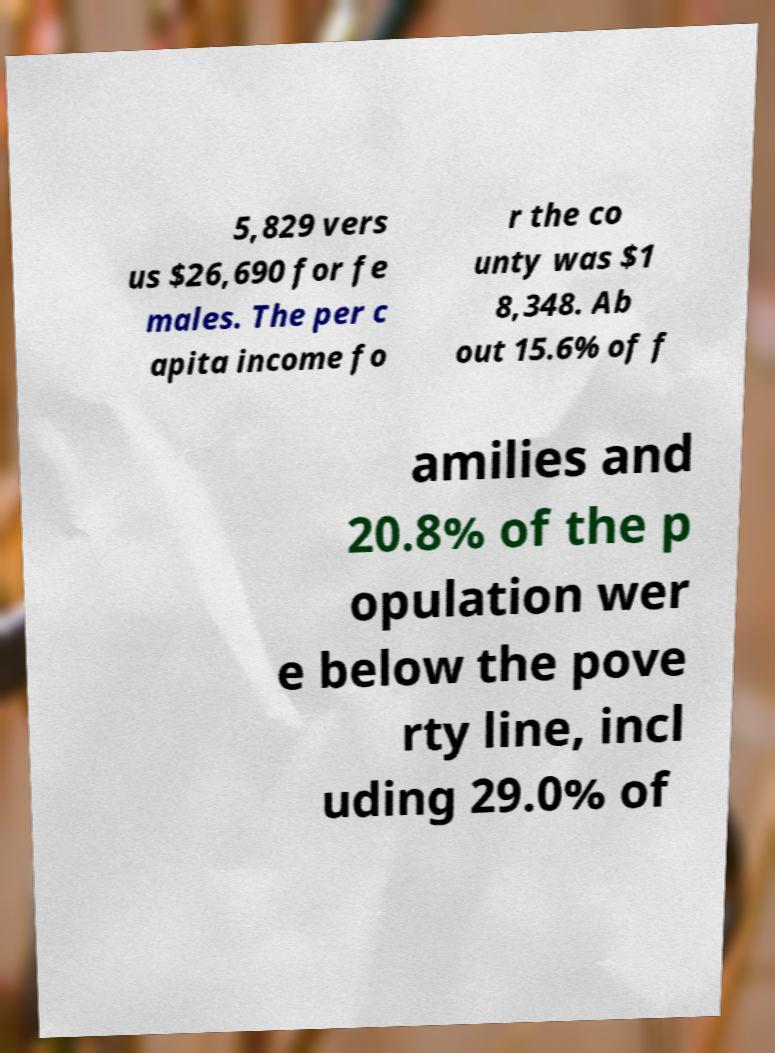Can you read and provide the text displayed in the image?This photo seems to have some interesting text. Can you extract and type it out for me? 5,829 vers us $26,690 for fe males. The per c apita income fo r the co unty was $1 8,348. Ab out 15.6% of f amilies and 20.8% of the p opulation wer e below the pove rty line, incl uding 29.0% of 